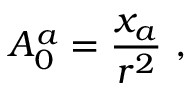Convert formula to latex. <formula><loc_0><loc_0><loc_500><loc_500>A _ { 0 } ^ { a } = \frac { x _ { a } } { r ^ { 2 } } ,</formula> 